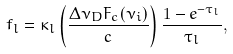Convert formula to latex. <formula><loc_0><loc_0><loc_500><loc_500>f _ { l } = \kappa _ { l } \left ( \frac { \Delta \nu _ { D } F _ { c } ( \nu _ { i } ) } { c } \right ) \frac { 1 - e ^ { - \tau _ { l } } } { \tau _ { l } } ,</formula> 